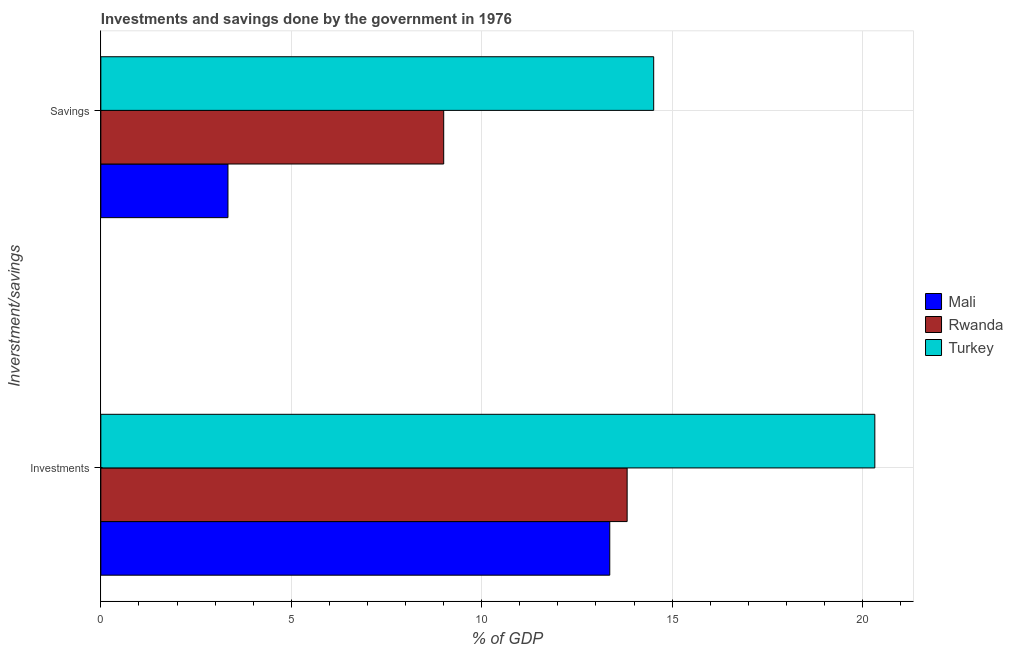How many different coloured bars are there?
Your response must be concise. 3. Are the number of bars per tick equal to the number of legend labels?
Make the answer very short. Yes. Are the number of bars on each tick of the Y-axis equal?
Your answer should be compact. Yes. How many bars are there on the 2nd tick from the top?
Ensure brevity in your answer.  3. What is the label of the 1st group of bars from the top?
Make the answer very short. Savings. What is the savings of government in Mali?
Provide a succinct answer. 3.34. Across all countries, what is the maximum investments of government?
Provide a short and direct response. 20.32. Across all countries, what is the minimum investments of government?
Your answer should be compact. 13.36. In which country was the investments of government maximum?
Make the answer very short. Turkey. In which country was the savings of government minimum?
Keep it short and to the point. Mali. What is the total savings of government in the graph?
Give a very brief answer. 26.86. What is the difference between the investments of government in Turkey and that in Rwanda?
Ensure brevity in your answer.  6.5. What is the difference between the savings of government in Turkey and the investments of government in Rwanda?
Your response must be concise. 0.7. What is the average investments of government per country?
Provide a succinct answer. 15.84. What is the difference between the savings of government and investments of government in Turkey?
Give a very brief answer. -5.81. In how many countries, is the savings of government greater than 12 %?
Your response must be concise. 1. What is the ratio of the savings of government in Rwanda to that in Mali?
Provide a succinct answer. 2.7. In how many countries, is the investments of government greater than the average investments of government taken over all countries?
Make the answer very short. 1. What does the 2nd bar from the top in Savings represents?
Offer a terse response. Rwanda. What does the 1st bar from the bottom in Savings represents?
Offer a terse response. Mali. How many bars are there?
Give a very brief answer. 6. Are the values on the major ticks of X-axis written in scientific E-notation?
Make the answer very short. No. Where does the legend appear in the graph?
Keep it short and to the point. Center right. How many legend labels are there?
Offer a terse response. 3. How are the legend labels stacked?
Provide a short and direct response. Vertical. What is the title of the graph?
Provide a succinct answer. Investments and savings done by the government in 1976. What is the label or title of the X-axis?
Offer a terse response. % of GDP. What is the label or title of the Y-axis?
Keep it short and to the point. Inverstment/savings. What is the % of GDP of Mali in Investments?
Offer a terse response. 13.36. What is the % of GDP in Rwanda in Investments?
Provide a short and direct response. 13.82. What is the % of GDP in Turkey in Investments?
Ensure brevity in your answer.  20.32. What is the % of GDP in Mali in Savings?
Ensure brevity in your answer.  3.34. What is the % of GDP of Rwanda in Savings?
Offer a very short reply. 9. What is the % of GDP in Turkey in Savings?
Give a very brief answer. 14.52. Across all Inverstment/savings, what is the maximum % of GDP of Mali?
Your answer should be very brief. 13.36. Across all Inverstment/savings, what is the maximum % of GDP in Rwanda?
Your answer should be very brief. 13.82. Across all Inverstment/savings, what is the maximum % of GDP of Turkey?
Ensure brevity in your answer.  20.32. Across all Inverstment/savings, what is the minimum % of GDP in Mali?
Keep it short and to the point. 3.34. Across all Inverstment/savings, what is the minimum % of GDP of Rwanda?
Provide a short and direct response. 9. Across all Inverstment/savings, what is the minimum % of GDP of Turkey?
Make the answer very short. 14.52. What is the total % of GDP in Mali in the graph?
Keep it short and to the point. 16.7. What is the total % of GDP of Rwanda in the graph?
Make the answer very short. 22.82. What is the total % of GDP in Turkey in the graph?
Make the answer very short. 34.84. What is the difference between the % of GDP of Mali in Investments and that in Savings?
Provide a short and direct response. 10.03. What is the difference between the % of GDP in Rwanda in Investments and that in Savings?
Ensure brevity in your answer.  4.82. What is the difference between the % of GDP of Turkey in Investments and that in Savings?
Provide a succinct answer. 5.81. What is the difference between the % of GDP of Mali in Investments and the % of GDP of Rwanda in Savings?
Your answer should be compact. 4.36. What is the difference between the % of GDP of Mali in Investments and the % of GDP of Turkey in Savings?
Provide a short and direct response. -1.15. What is the difference between the % of GDP of Rwanda in Investments and the % of GDP of Turkey in Savings?
Your answer should be very brief. -0.7. What is the average % of GDP in Mali per Inverstment/savings?
Make the answer very short. 8.35. What is the average % of GDP of Rwanda per Inverstment/savings?
Your answer should be very brief. 11.41. What is the average % of GDP of Turkey per Inverstment/savings?
Make the answer very short. 17.42. What is the difference between the % of GDP of Mali and % of GDP of Rwanda in Investments?
Offer a very short reply. -0.46. What is the difference between the % of GDP of Mali and % of GDP of Turkey in Investments?
Provide a short and direct response. -6.96. What is the difference between the % of GDP in Rwanda and % of GDP in Turkey in Investments?
Your response must be concise. -6.5. What is the difference between the % of GDP in Mali and % of GDP in Rwanda in Savings?
Offer a terse response. -5.66. What is the difference between the % of GDP in Mali and % of GDP in Turkey in Savings?
Your answer should be very brief. -11.18. What is the difference between the % of GDP in Rwanda and % of GDP in Turkey in Savings?
Provide a short and direct response. -5.51. What is the ratio of the % of GDP of Mali in Investments to that in Savings?
Offer a very short reply. 4. What is the ratio of the % of GDP of Rwanda in Investments to that in Savings?
Keep it short and to the point. 1.53. What is the ratio of the % of GDP in Turkey in Investments to that in Savings?
Keep it short and to the point. 1.4. What is the difference between the highest and the second highest % of GDP in Mali?
Your answer should be compact. 10.03. What is the difference between the highest and the second highest % of GDP of Rwanda?
Provide a short and direct response. 4.82. What is the difference between the highest and the second highest % of GDP in Turkey?
Give a very brief answer. 5.81. What is the difference between the highest and the lowest % of GDP in Mali?
Provide a succinct answer. 10.03. What is the difference between the highest and the lowest % of GDP of Rwanda?
Your response must be concise. 4.82. What is the difference between the highest and the lowest % of GDP of Turkey?
Provide a short and direct response. 5.81. 